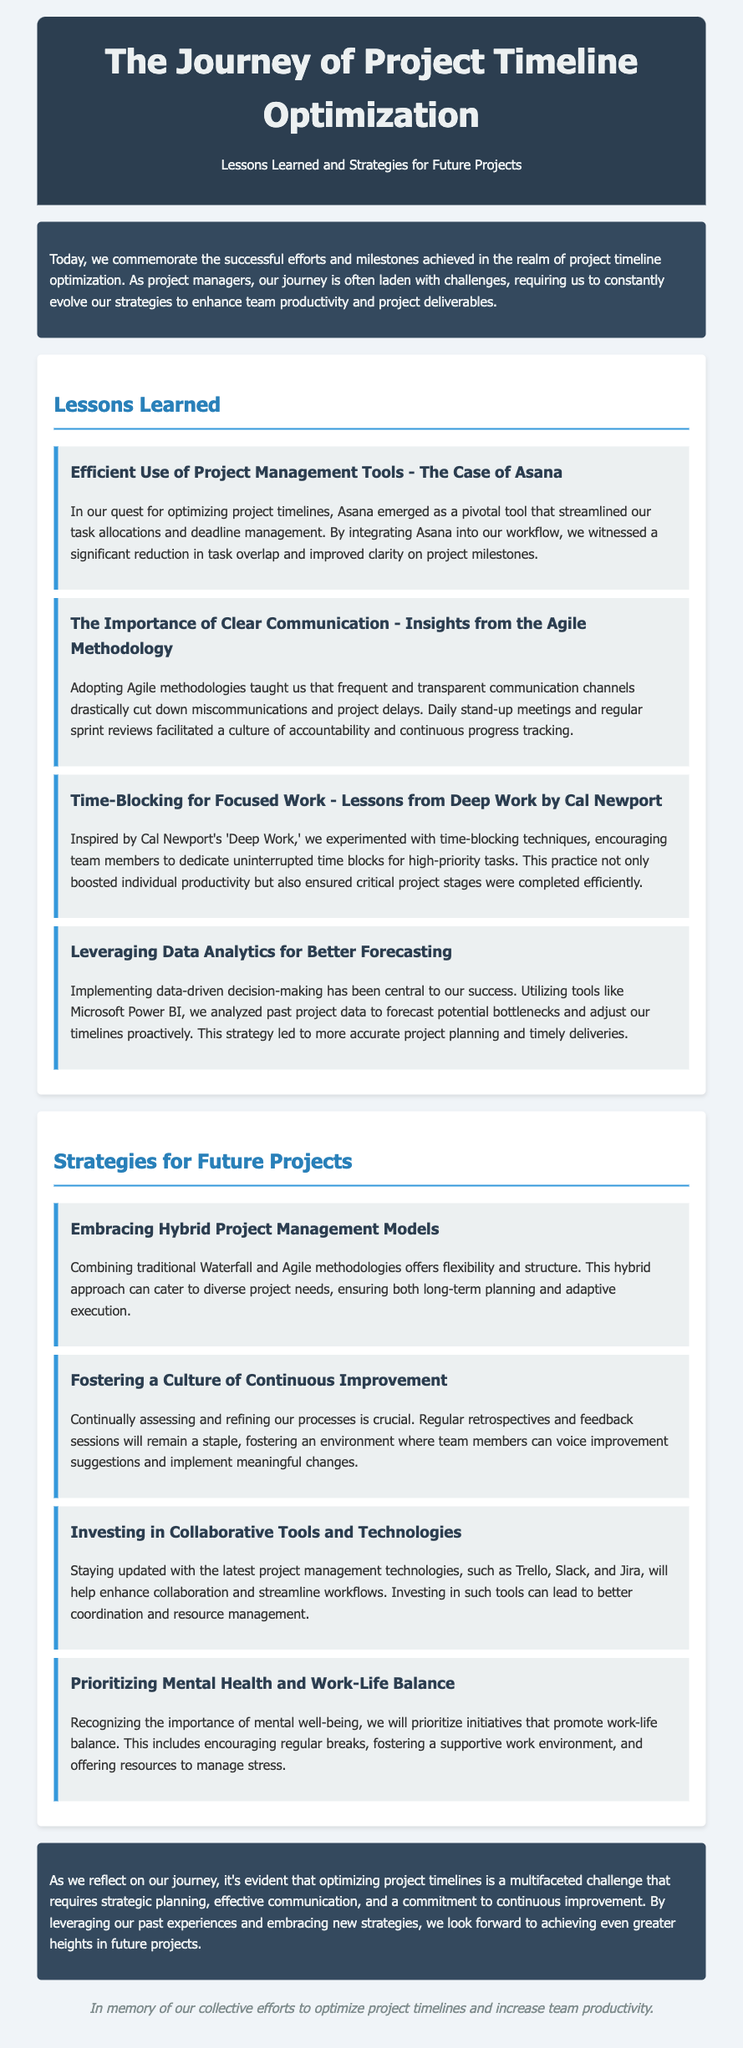What is the title of the document? The title is presented prominently at the top of the document, indicating the main focus of the content.
Answer: The Journey of Project Timeline Optimization What is one tool mentioned for project management? The document lists specific tools that helped with project optimization, highlighting their significance in the process.
Answer: Asana How many lessons learned are discussed? The document enumerates specific lessons learned, providing a count of them.
Answer: Four What methodology is referenced for clear communication? The document mentions a specific methodology that emphasizes communication, linking it to practices that enhanced project outcomes.
Answer: Agile What approach combines Waterfall and Agile methodologies? The content discusses a specific strategy that merges two different project management methodologies, indicating its benefits.
Answer: Hybrid Project Management Models What is a strategy for promoting work-life balance? The document lists strategies, including initiatives aimed at maintaining mental health and a balanced work-life, as part of future projects.
Answer: Prioritizing Mental Health What did time-blocking help improve? The document suggests the effect of time-blocking techniques on team productivity and task management.
Answer: Individual productivity What is emphasized as a culture to be fostered in future projects? The document highlights an ongoing commitment towards enhancing certain aspects of the work environment to improve project management.
Answer: Continuous Improvement 